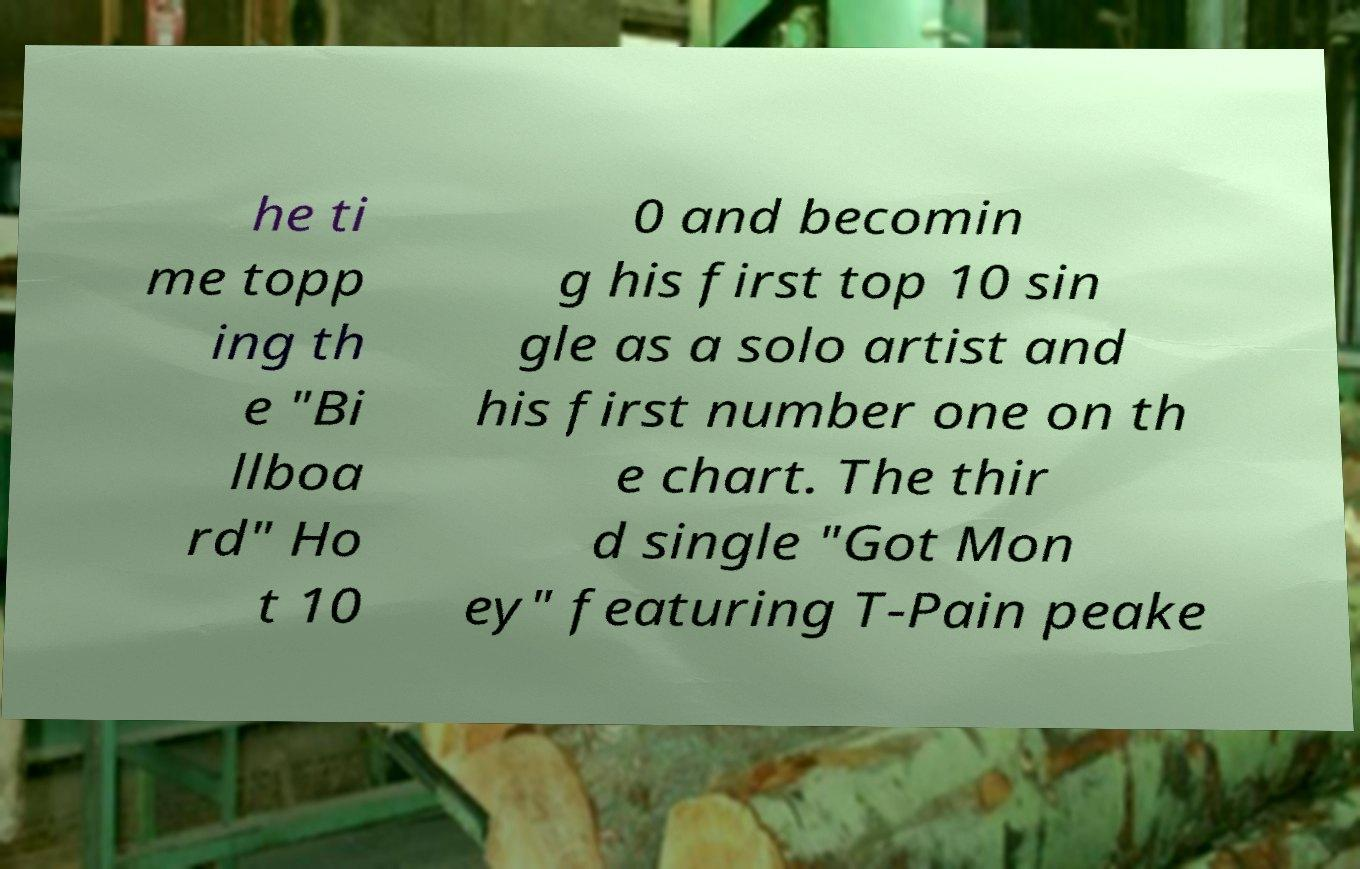Please identify and transcribe the text found in this image. he ti me topp ing th e "Bi llboa rd" Ho t 10 0 and becomin g his first top 10 sin gle as a solo artist and his first number one on th e chart. The thir d single "Got Mon ey" featuring T-Pain peake 